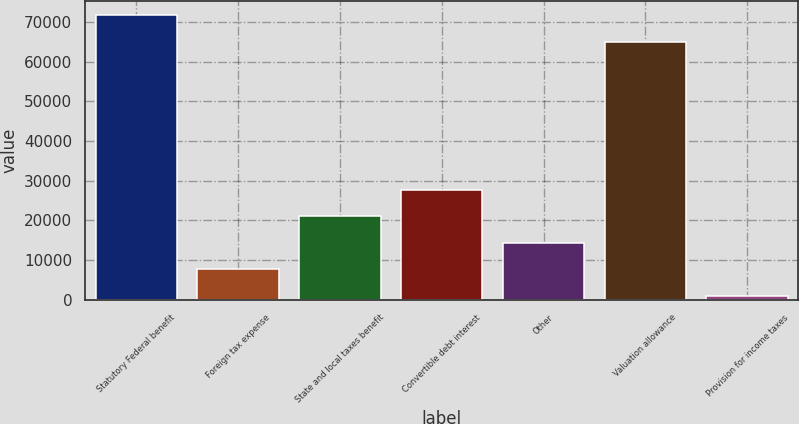Convert chart. <chart><loc_0><loc_0><loc_500><loc_500><bar_chart><fcel>Statutory Federal benefit<fcel>Foreign tax expense<fcel>State and local taxes benefit<fcel>Convertible debt interest<fcel>Other<fcel>Valuation allowance<fcel>Provision for income taxes<nl><fcel>71766.1<fcel>7674.1<fcel>21012.3<fcel>27681.4<fcel>14343.2<fcel>65097<fcel>1005<nl></chart> 